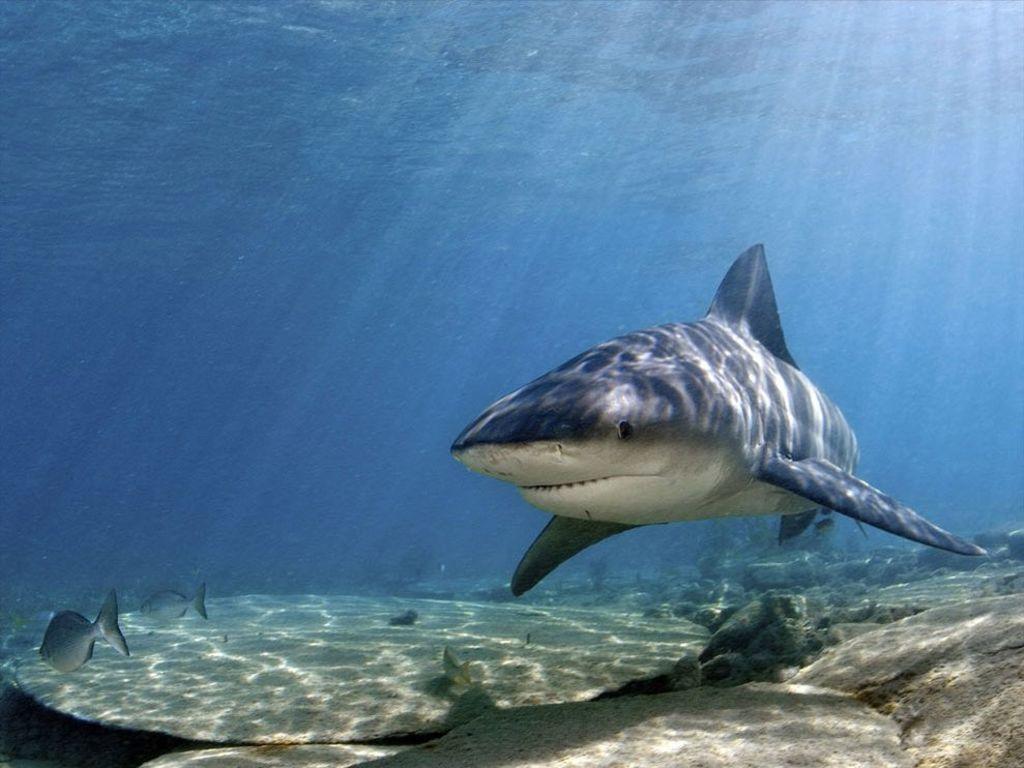How would you summarize this image in a sentence or two? In this picture, we see a shark and the fishes are swimming in the water. At the bottom, we see the sand and the stones. In the background, we see water and this water might be in the sea. 